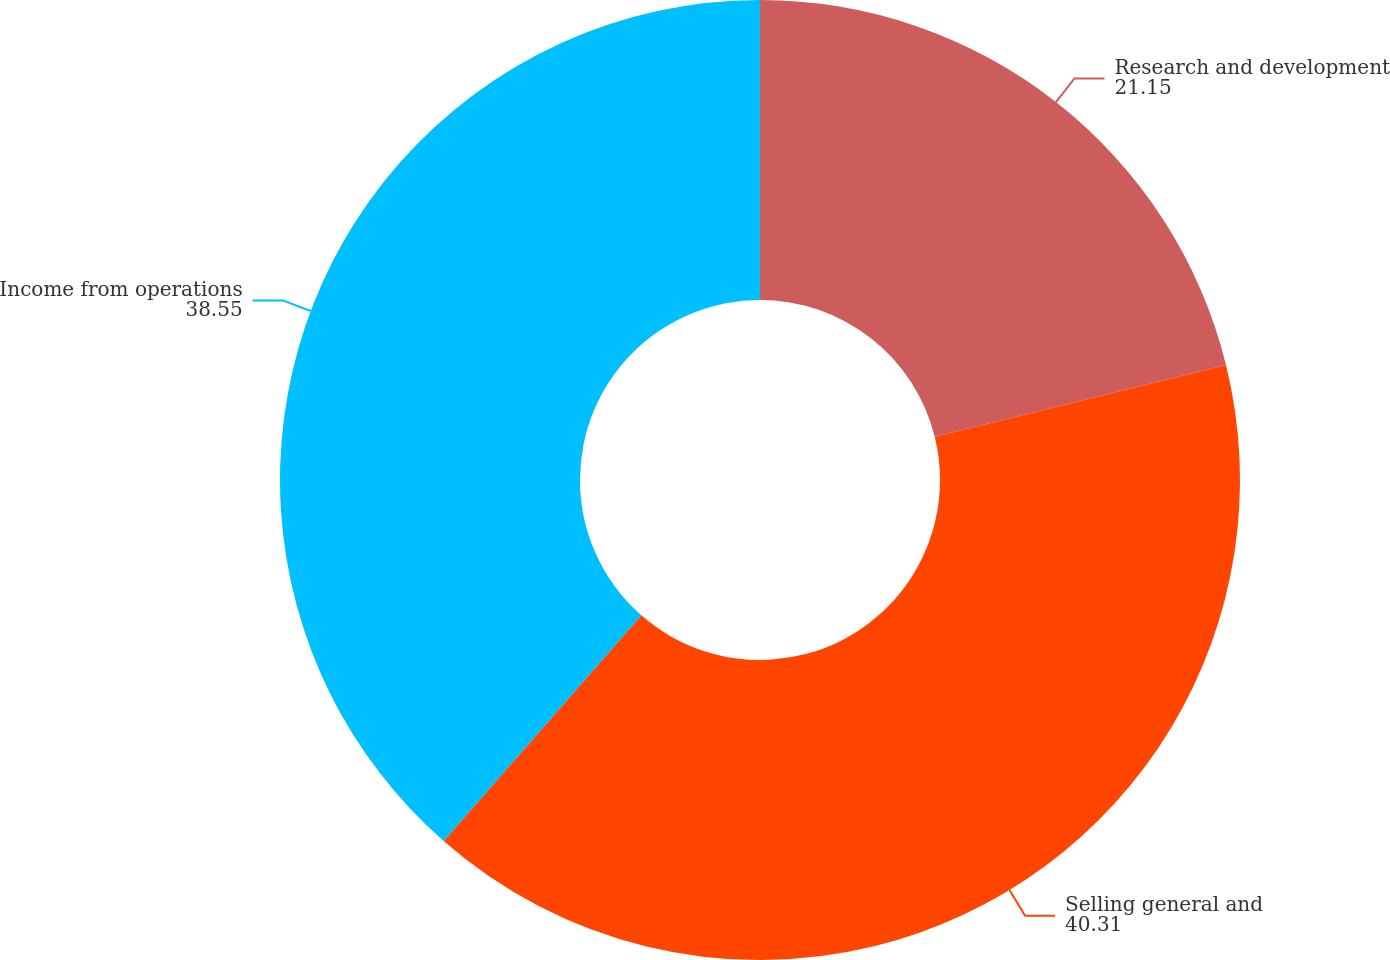<chart> <loc_0><loc_0><loc_500><loc_500><pie_chart><fcel>Research and development<fcel>Selling general and<fcel>Income from operations<nl><fcel>21.15%<fcel>40.31%<fcel>38.55%<nl></chart> 